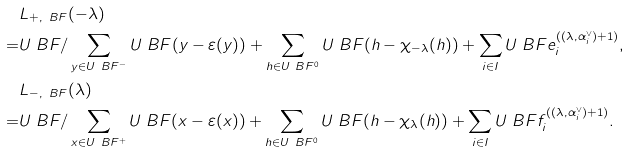<formula> <loc_0><loc_0><loc_500><loc_500>& L _ { + , \ B F } ( - \lambda ) \\ = & U _ { \ } B F / \sum _ { y \in U _ { \ } B F ^ { - } } U _ { \ } B F ( y - \varepsilon ( y ) ) + \sum _ { h \in U _ { \ } B F ^ { 0 } } U _ { \ } B F ( h - \chi _ { - \lambda } ( h ) ) + \sum _ { i \in I } U _ { \ } B F e _ { i } ^ { ( ( \lambda , \alpha _ { i } ^ { \vee } ) + 1 ) } , \\ & L _ { - , \ B F } ( \lambda ) \\ = & U _ { \ } B F / \sum _ { x \in U _ { \ } B F ^ { + } } U _ { \ } B F ( x - \varepsilon ( x ) ) + \sum _ { h \in U _ { \ } B F ^ { 0 } } U _ { \ } B F ( h - \chi _ { \lambda } ( h ) ) + \sum _ { i \in I } U _ { \ } B F f _ { i } ^ { ( ( \lambda , \alpha _ { i } ^ { \vee } ) + 1 ) } .</formula> 